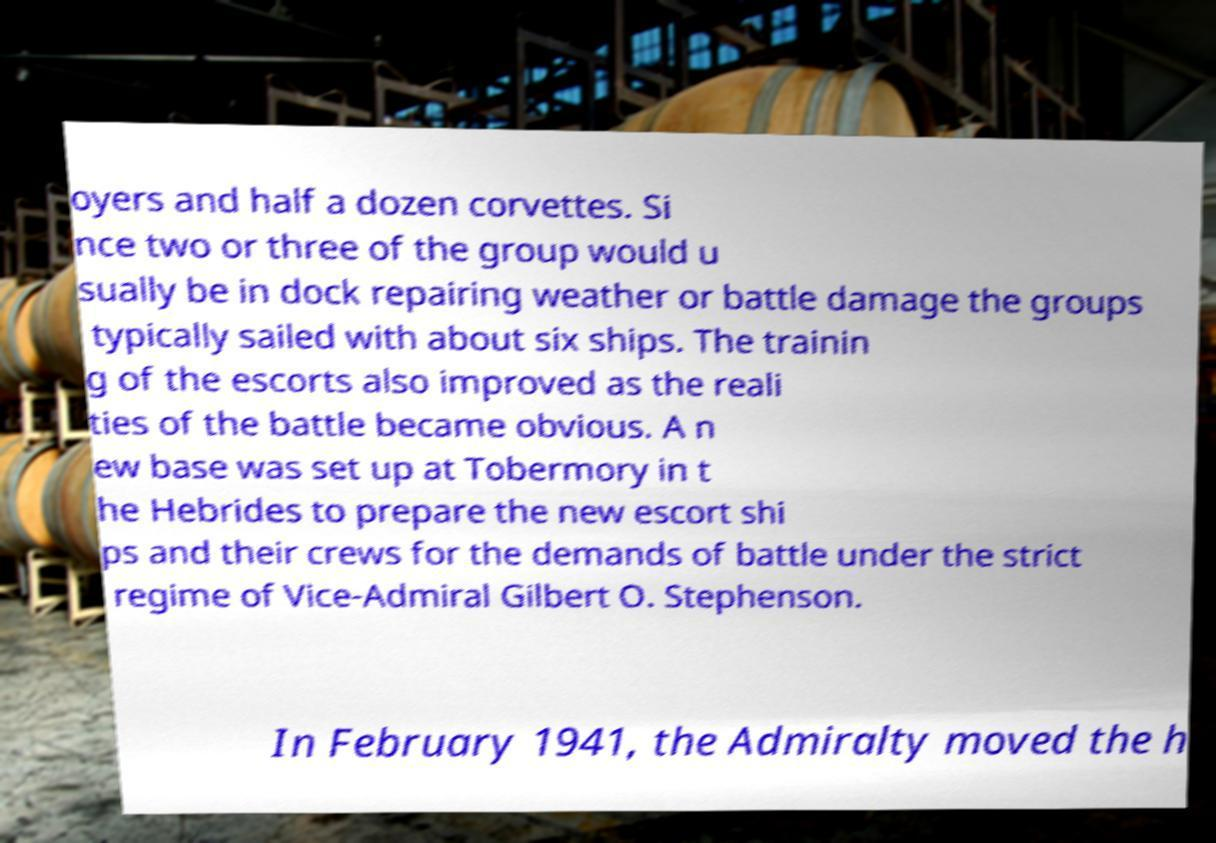Please read and relay the text visible in this image. What does it say? oyers and half a dozen corvettes. Si nce two or three of the group would u sually be in dock repairing weather or battle damage the groups typically sailed with about six ships. The trainin g of the escorts also improved as the reali ties of the battle became obvious. A n ew base was set up at Tobermory in t he Hebrides to prepare the new escort shi ps and their crews for the demands of battle under the strict regime of Vice-Admiral Gilbert O. Stephenson. In February 1941, the Admiralty moved the h 